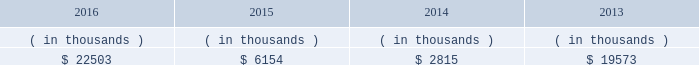Entergy louisiana , llc and subsidiaries management 2019s financial discussion and analysis entergy louisiana may refinance , redeem , or otherwise retire debt prior to maturity , to the extent market conditions and interest and distribution rates are favorable .
All debt and common and preferred membership interest issuances by entergy louisiana require prior regulatory approval .
Preferred membership interest and debt issuances are also subject to issuance tests set forth in its bond indentures and other agreements .
Entergy louisiana has sufficient capacity under these tests to meet its foreseeable capital needs .
Entergy louisiana 2019s receivables from the money pool were as follows as of december 31 for each of the following years. .
See note 4 to the financial statements for a description of the money pool .
Entergy louisiana has a credit facility in the amount of $ 350 million scheduled to expire in august 2021 .
The credit facility allows entergy louisiana to issue letters of credit against 50% ( 50 % ) of the borrowing capacity of the facility .
As of december 31 , 2016 , there were no cash borrowings and a $ 6.4 million letter of credit outstanding under the credit facility .
In addition , entergy louisiana is party to an uncommitted letter of credit facility as a means to post collateral to support its obligations under miso .
As of december 31 , 2016 , a $ 5.7 million letter of credit was outstanding under entergy louisiana 2019s uncommitted letter of credit facility .
See note 4 to the financial statements for additional discussion of the credit facilities .
The entergy louisiana nuclear fuel company variable interest entities have two separate credit facilities , one in the amount of $ 105 million and one in the amount of $ 85 million , both scheduled to expire in may 2019 .
As of december 31 , 2016 , $ 3.8 million of letters of credit were outstanding under the credit facility to support a like amount of commercial paper issued by the entergy louisiana waterford 3 nuclear fuel company variable interest entity and there were no cash borrowings outstanding under the credit facility for the entergy louisiana river bend nuclear fuel company variable interest entity .
See note 4 to the financial statements for additional discussion of the nuclear fuel company variable interest entity credit facility .
Entergy louisiana obtained authorizations from the ferc through october 2017 for the following : 2022 short-term borrowings not to exceed an aggregate amount of $ 450 million at any time outstanding ; 2022 long-term borrowings and security issuances ; and 2022 long-term borrowings by its nuclear fuel company variable interest entities .
See note 4 to the financial statements for further discussion of entergy louisiana 2019s short-term borrowing limits .
Hurricane isaac in june 2014 the lpsc voted to approve a series of orders which ( i ) quantified $ 290.8 million of hurricane isaac system restoration costs as prudently incurred ; ( ii ) determined $ 290 million as the level of storm reserves to be re-established ; ( iii ) authorized entergy louisiana to utilize louisiana act 55 financing for hurricane isaac system restoration costs ; and ( iv ) granted other requested relief associated with storm reserves and act 55 financing of hurricane isaac system restoration costs .
Entergy louisiana committed to pass on to customers a minimum of $ 30.8 million of customer benefits through annual customer credits of approximately $ 6.2 million for five years .
Approvals for the act 55 financings were obtained from the louisiana utilities restoration corporation and the louisiana state bond commission .
See note 2 to the financial statements for a discussion of the august 2014 issuance of bonds under act 55 of the louisiana legislature. .
The company had several letters of credit outstanding . as of december 31 , 2016 , what was the total amount outstanding under the august 2021 facility and the entergy louisiana facility , in millions?\\n\\n? 
Computations: (5.7 + 6.4)
Answer: 12.1. Entergy louisiana , llc and subsidiaries management 2019s financial discussion and analysis entergy louisiana may refinance , redeem , or otherwise retire debt prior to maturity , to the extent market conditions and interest and distribution rates are favorable .
All debt and common and preferred membership interest issuances by entergy louisiana require prior regulatory approval .
Preferred membership interest and debt issuances are also subject to issuance tests set forth in its bond indentures and other agreements .
Entergy louisiana has sufficient capacity under these tests to meet its foreseeable capital needs .
Entergy louisiana 2019s receivables from the money pool were as follows as of december 31 for each of the following years. .
See note 4 to the financial statements for a description of the money pool .
Entergy louisiana has a credit facility in the amount of $ 350 million scheduled to expire in august 2021 .
The credit facility allows entergy louisiana to issue letters of credit against 50% ( 50 % ) of the borrowing capacity of the facility .
As of december 31 , 2016 , there were no cash borrowings and a $ 6.4 million letter of credit outstanding under the credit facility .
In addition , entergy louisiana is party to an uncommitted letter of credit facility as a means to post collateral to support its obligations under miso .
As of december 31 , 2016 , a $ 5.7 million letter of credit was outstanding under entergy louisiana 2019s uncommitted letter of credit facility .
See note 4 to the financial statements for additional discussion of the credit facilities .
The entergy louisiana nuclear fuel company variable interest entities have two separate credit facilities , one in the amount of $ 105 million and one in the amount of $ 85 million , both scheduled to expire in may 2019 .
As of december 31 , 2016 , $ 3.8 million of letters of credit were outstanding under the credit facility to support a like amount of commercial paper issued by the entergy louisiana waterford 3 nuclear fuel company variable interest entity and there were no cash borrowings outstanding under the credit facility for the entergy louisiana river bend nuclear fuel company variable interest entity .
See note 4 to the financial statements for additional discussion of the nuclear fuel company variable interest entity credit facility .
Entergy louisiana obtained authorizations from the ferc through october 2017 for the following : 2022 short-term borrowings not to exceed an aggregate amount of $ 450 million at any time outstanding ; 2022 long-term borrowings and security issuances ; and 2022 long-term borrowings by its nuclear fuel company variable interest entities .
See note 4 to the financial statements for further discussion of entergy louisiana 2019s short-term borrowing limits .
Hurricane isaac in june 2014 the lpsc voted to approve a series of orders which ( i ) quantified $ 290.8 million of hurricane isaac system restoration costs as prudently incurred ; ( ii ) determined $ 290 million as the level of storm reserves to be re-established ; ( iii ) authorized entergy louisiana to utilize louisiana act 55 financing for hurricane isaac system restoration costs ; and ( iv ) granted other requested relief associated with storm reserves and act 55 financing of hurricane isaac system restoration costs .
Entergy louisiana committed to pass on to customers a minimum of $ 30.8 million of customer benefits through annual customer credits of approximately $ 6.2 million for five years .
Approvals for the act 55 financings were obtained from the louisiana utilities restoration corporation and the louisiana state bond commission .
See note 2 to the financial statements for a discussion of the august 2014 issuance of bonds under act 55 of the louisiana legislature. .
If the entergy louisiana commitment for customer benefits was limited to four years , how much would customers receive in millions? 
Computations: (((6.2 + 6.2) + 6.2) + 6.2)
Answer: 24.8. 